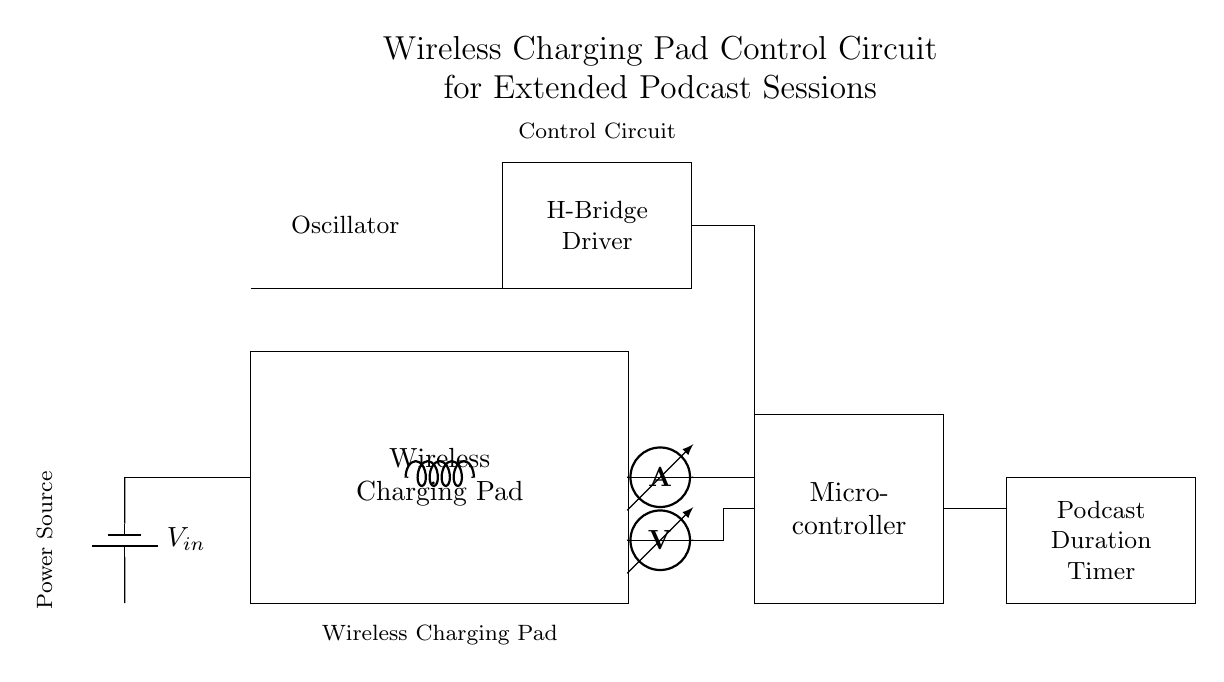What components are in the circuit? The circuit includes a wireless charging pad, a power source, a microcontroller, an oscillator, an H-bridge driver, a coil, a current sensor, a voltage sensor, and a podcast duration timer.
Answer: wireless charging pad, power source, microcontroller, oscillator, H-bridge driver, coil, current sensor, voltage sensor, podcast duration timer What is the purpose of the H-bridge driver? The H-bridge driver controls the direction of the current through the coil to enable efficient wireless power transfer.
Answer: Current direction control How is the microcontroller powered? The microcontroller is powered by the battery through the connections indicated in the circuit diagram.
Answer: Battery What does the podcast duration timer do? The podcast duration timer tracks how long the podcast session has been ongoing, ensuring the system operates optimally.
Answer: Tracks duration How are the current and voltage sensors connected? The current and voltage sensors are connected in a series configuration to the H-bridge driver and are monitored by the microcontroller for efficient operation.
Answer: Series configuration What type of oscillator is used in this circuit? The circuit uses a sinusoidal oscillator to generate the appropriate frequency for wireless charging.
Answer: Sinusoidal 